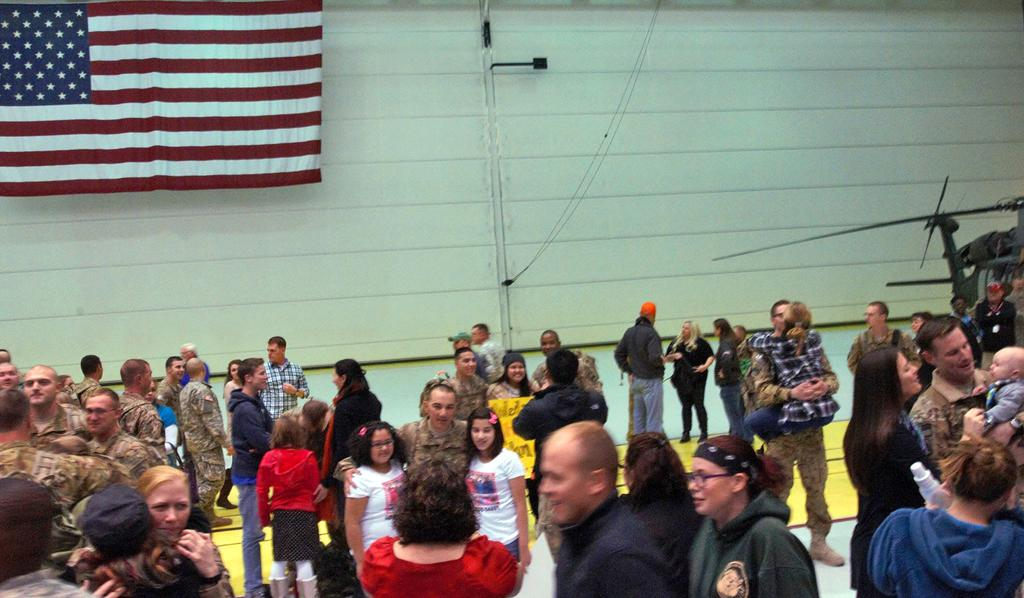How many people are in the group visible in the image? There is a group of people standing in the image, but the exact number cannot be determined from the provided facts. What can be seen in the background of the image? There is a flag and a wall in the background of the image. What is attached to the wall in the background of the image? There is an object attached to the wall in the background of the image, but its nature is not specified in the provided facts. What is located on the right side of the image? There is a helicopter on the right side of the image. How many beans are present in the image? There is no mention of beans in the provided facts, so it cannot be determined if any are present in the image. 